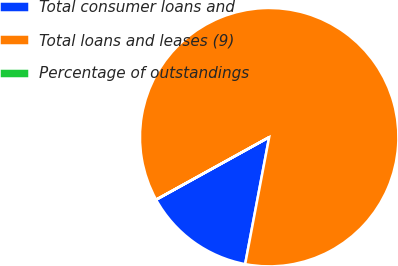Convert chart to OTSL. <chart><loc_0><loc_0><loc_500><loc_500><pie_chart><fcel>Total consumer loans and<fcel>Total loans and leases (9)<fcel>Percentage of outstandings<nl><fcel>13.98%<fcel>86.01%<fcel>0.01%<nl></chart> 